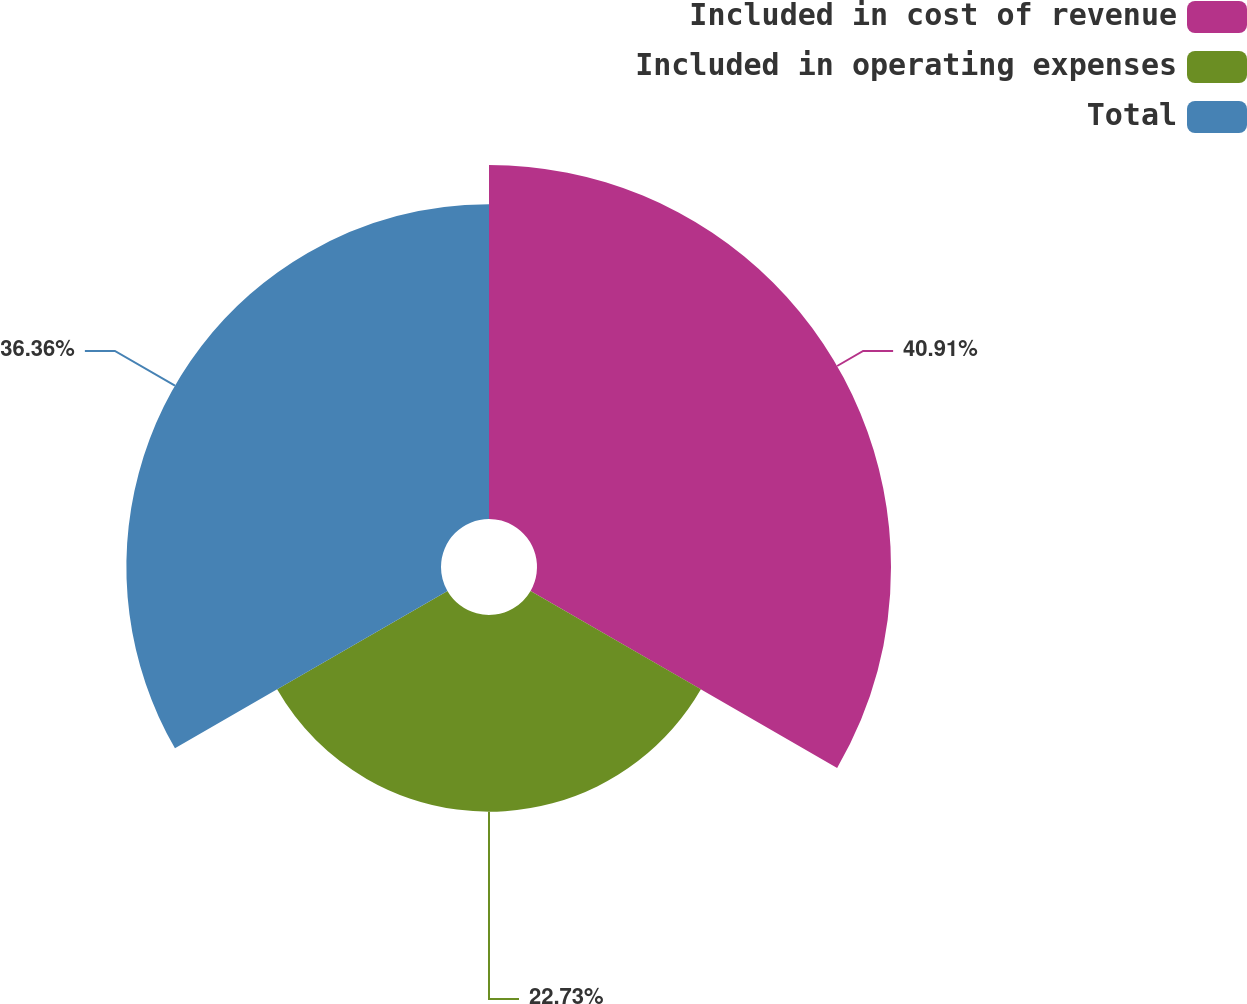<chart> <loc_0><loc_0><loc_500><loc_500><pie_chart><fcel>Included in cost of revenue<fcel>Included in operating expenses<fcel>Total<nl><fcel>40.91%<fcel>22.73%<fcel>36.36%<nl></chart> 